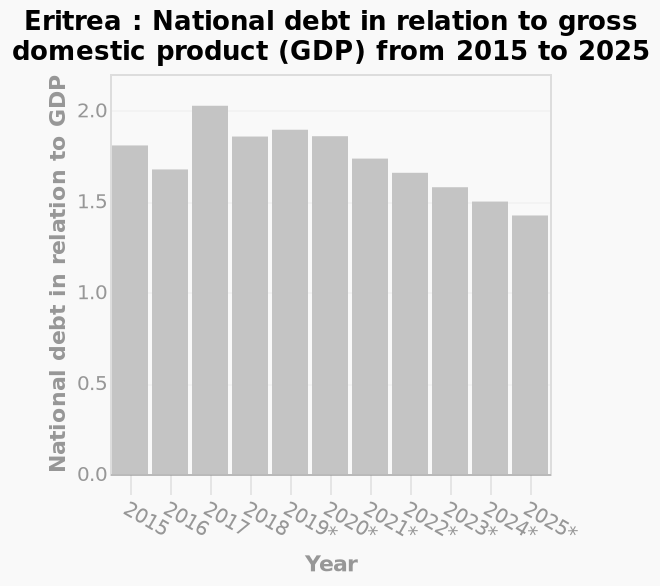<image>
What does the x-axis represent in the bar diagram?  The x-axis represents the years from 2015 to 2025. What is the projected value of the figure in 2025? The projected value of the figure in 2025 is just under 1.5. What does the y-axis measure in the bar diagram? The y-axis measures the national debt in relation to gross domestic product (GDP). When did the slight spike occur?  The slight spike occurred in 2017. 